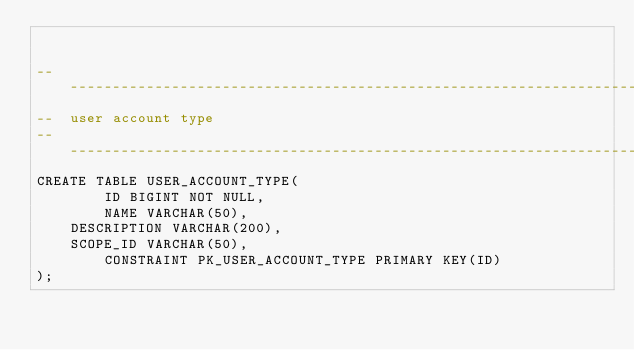Convert code to text. <code><loc_0><loc_0><loc_500><loc_500><_SQL_>

-------------------------------------------------------------------------------
--  user account type
-------------------------------------------------------------------------------
CREATE TABLE USER_ACCOUNT_TYPE(
        ID BIGINT NOT NULL,
        NAME VARCHAR(50),
	DESCRIPTION VARCHAR(200),
	SCOPE_ID VARCHAR(50),
        CONSTRAINT PK_USER_ACCOUNT_TYPE PRIMARY KEY(ID)
);

</code> 